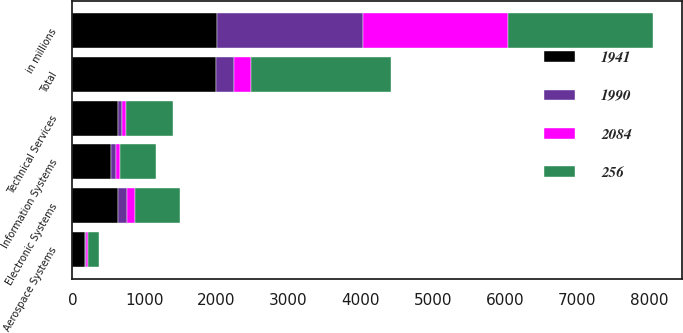<chart> <loc_0><loc_0><loc_500><loc_500><stacked_bar_chart><ecel><fcel>in millions<fcel>Aerospace Systems<fcel>Electronic Systems<fcel>Information Systems<fcel>Technical Services<fcel>Total<nl><fcel>1941<fcel>2014<fcel>176<fcel>637<fcel>537<fcel>640<fcel>1990<nl><fcel>2084<fcel>2014<fcel>22<fcel>109<fcel>57<fcel>48<fcel>236<nl><fcel>256<fcel>2013<fcel>149<fcel>629<fcel>504<fcel>659<fcel>1941<nl><fcel>1990<fcel>2013<fcel>18<fcel>125<fcel>63<fcel>50<fcel>256<nl></chart> 